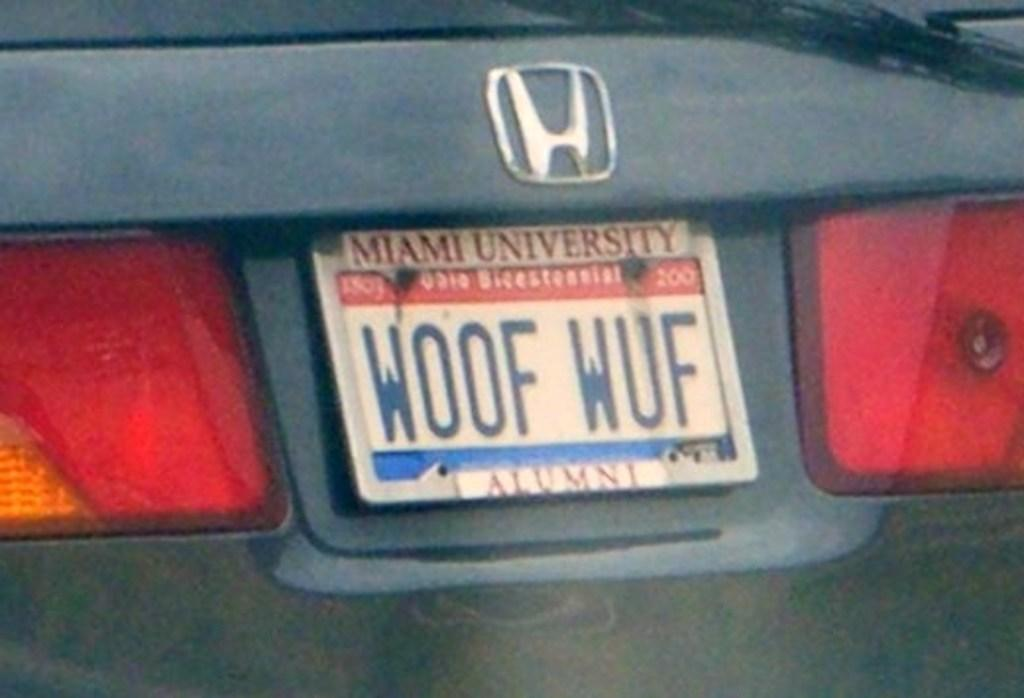<image>
Share a concise interpretation of the image provided. a person from Ohio has a license plate with a miami university surround 